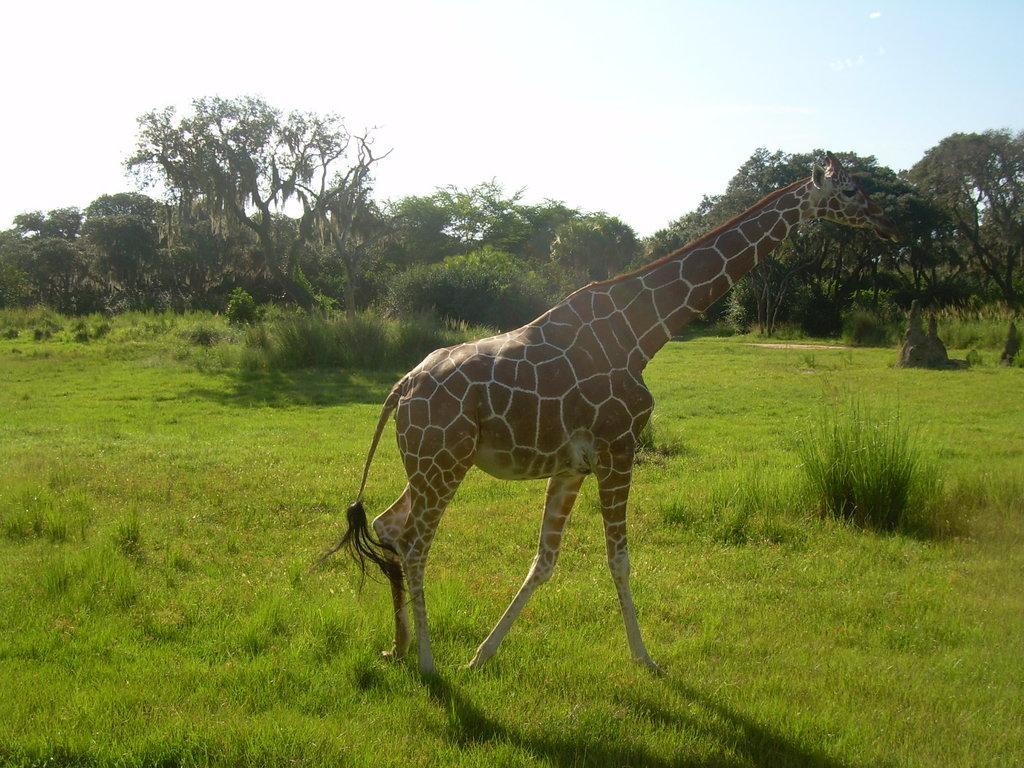Please provide a concise description of this image. Land is covered with grass. Giraffe is facing towards the right side of the image. Background there are trees and plants.  